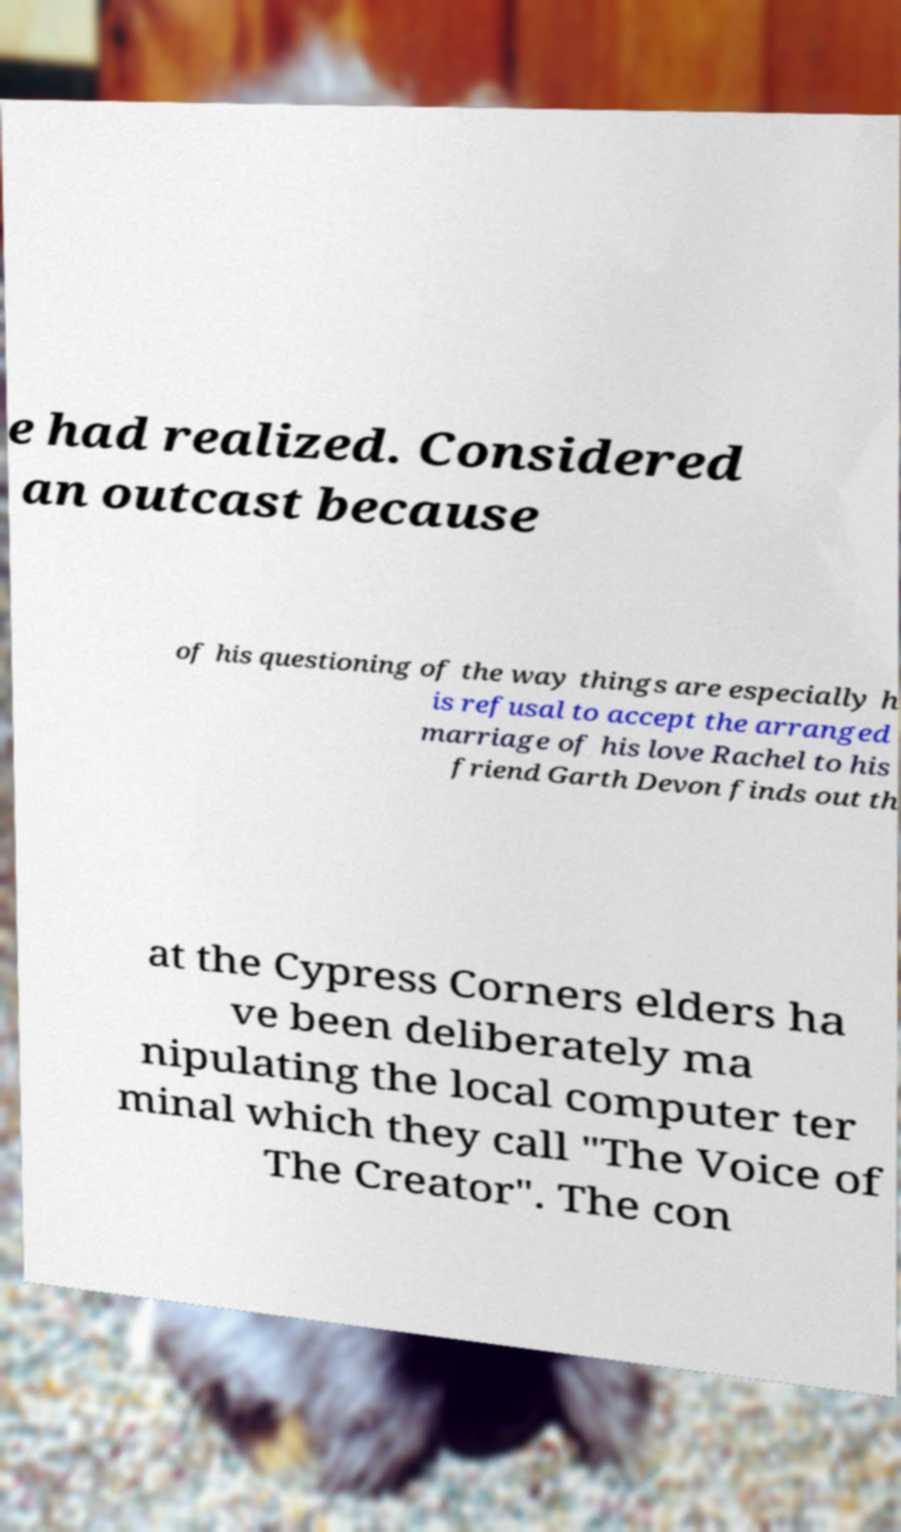What messages or text are displayed in this image? I need them in a readable, typed format. e had realized. Considered an outcast because of his questioning of the way things are especially h is refusal to accept the arranged marriage of his love Rachel to his friend Garth Devon finds out th at the Cypress Corners elders ha ve been deliberately ma nipulating the local computer ter minal which they call "The Voice of The Creator". The con 